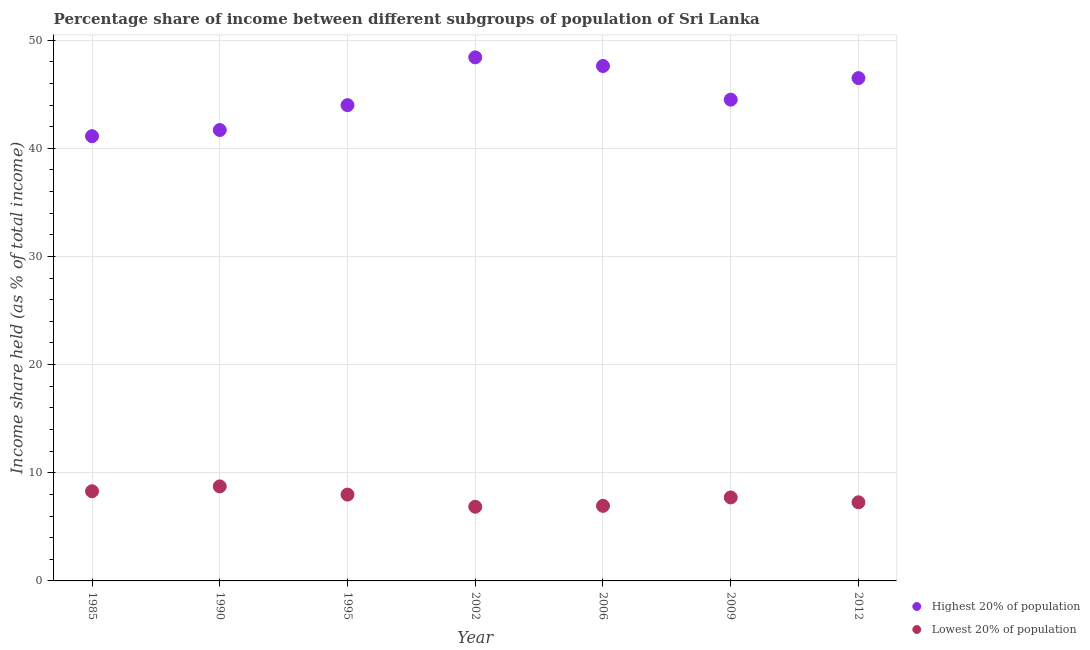What is the income share held by highest 20% of the population in 1985?
Provide a short and direct response. 41.12. Across all years, what is the maximum income share held by lowest 20% of the population?
Offer a terse response. 8.74. Across all years, what is the minimum income share held by highest 20% of the population?
Give a very brief answer. 41.12. In which year was the income share held by highest 20% of the population minimum?
Offer a very short reply. 1985. What is the total income share held by lowest 20% of the population in the graph?
Provide a short and direct response. 53.8. What is the difference between the income share held by lowest 20% of the population in 2002 and that in 2009?
Give a very brief answer. -0.86. What is the difference between the income share held by lowest 20% of the population in 2002 and the income share held by highest 20% of the population in 1995?
Your response must be concise. -37.13. What is the average income share held by highest 20% of the population per year?
Offer a terse response. 44.83. In the year 1990, what is the difference between the income share held by lowest 20% of the population and income share held by highest 20% of the population?
Your answer should be very brief. -32.95. What is the ratio of the income share held by lowest 20% of the population in 2002 to that in 2012?
Ensure brevity in your answer.  0.94. Is the income share held by highest 20% of the population in 1985 less than that in 1990?
Offer a very short reply. Yes. Is the difference between the income share held by lowest 20% of the population in 2002 and 2012 greater than the difference between the income share held by highest 20% of the population in 2002 and 2012?
Keep it short and to the point. No. What is the difference between the highest and the second highest income share held by highest 20% of the population?
Keep it short and to the point. 0.8. What is the difference between the highest and the lowest income share held by highest 20% of the population?
Provide a succinct answer. 7.29. Is the sum of the income share held by lowest 20% of the population in 2006 and 2009 greater than the maximum income share held by highest 20% of the population across all years?
Keep it short and to the point. No. Does the income share held by highest 20% of the population monotonically increase over the years?
Your answer should be very brief. No. Is the income share held by highest 20% of the population strictly greater than the income share held by lowest 20% of the population over the years?
Your response must be concise. Yes. Is the income share held by highest 20% of the population strictly less than the income share held by lowest 20% of the population over the years?
Offer a very short reply. No. How many years are there in the graph?
Ensure brevity in your answer.  7. Are the values on the major ticks of Y-axis written in scientific E-notation?
Offer a very short reply. No. Does the graph contain any zero values?
Your answer should be very brief. No. How are the legend labels stacked?
Offer a very short reply. Vertical. What is the title of the graph?
Your answer should be compact. Percentage share of income between different subgroups of population of Sri Lanka. Does "Private creditors" appear as one of the legend labels in the graph?
Your response must be concise. No. What is the label or title of the X-axis?
Provide a short and direct response. Year. What is the label or title of the Y-axis?
Provide a succinct answer. Income share held (as % of total income). What is the Income share held (as % of total income) of Highest 20% of population in 1985?
Offer a very short reply. 41.12. What is the Income share held (as % of total income) in Lowest 20% of population in 1985?
Provide a short and direct response. 8.29. What is the Income share held (as % of total income) in Highest 20% of population in 1990?
Your response must be concise. 41.69. What is the Income share held (as % of total income) of Lowest 20% of population in 1990?
Offer a very short reply. 8.74. What is the Income share held (as % of total income) in Highest 20% of population in 1995?
Keep it short and to the point. 43.99. What is the Income share held (as % of total income) in Lowest 20% of population in 1995?
Give a very brief answer. 7.98. What is the Income share held (as % of total income) in Highest 20% of population in 2002?
Provide a short and direct response. 48.41. What is the Income share held (as % of total income) of Lowest 20% of population in 2002?
Offer a terse response. 6.86. What is the Income share held (as % of total income) in Highest 20% of population in 2006?
Your answer should be very brief. 47.61. What is the Income share held (as % of total income) in Lowest 20% of population in 2006?
Offer a very short reply. 6.94. What is the Income share held (as % of total income) of Highest 20% of population in 2009?
Offer a terse response. 44.5. What is the Income share held (as % of total income) in Lowest 20% of population in 2009?
Ensure brevity in your answer.  7.72. What is the Income share held (as % of total income) of Highest 20% of population in 2012?
Ensure brevity in your answer.  46.49. What is the Income share held (as % of total income) in Lowest 20% of population in 2012?
Provide a short and direct response. 7.27. Across all years, what is the maximum Income share held (as % of total income) in Highest 20% of population?
Make the answer very short. 48.41. Across all years, what is the maximum Income share held (as % of total income) of Lowest 20% of population?
Your response must be concise. 8.74. Across all years, what is the minimum Income share held (as % of total income) in Highest 20% of population?
Keep it short and to the point. 41.12. Across all years, what is the minimum Income share held (as % of total income) of Lowest 20% of population?
Keep it short and to the point. 6.86. What is the total Income share held (as % of total income) of Highest 20% of population in the graph?
Your answer should be compact. 313.81. What is the total Income share held (as % of total income) of Lowest 20% of population in the graph?
Offer a very short reply. 53.8. What is the difference between the Income share held (as % of total income) of Highest 20% of population in 1985 and that in 1990?
Offer a very short reply. -0.57. What is the difference between the Income share held (as % of total income) in Lowest 20% of population in 1985 and that in 1990?
Offer a very short reply. -0.45. What is the difference between the Income share held (as % of total income) in Highest 20% of population in 1985 and that in 1995?
Offer a terse response. -2.87. What is the difference between the Income share held (as % of total income) of Lowest 20% of population in 1985 and that in 1995?
Make the answer very short. 0.31. What is the difference between the Income share held (as % of total income) in Highest 20% of population in 1985 and that in 2002?
Make the answer very short. -7.29. What is the difference between the Income share held (as % of total income) in Lowest 20% of population in 1985 and that in 2002?
Your answer should be compact. 1.43. What is the difference between the Income share held (as % of total income) in Highest 20% of population in 1985 and that in 2006?
Your answer should be compact. -6.49. What is the difference between the Income share held (as % of total income) of Lowest 20% of population in 1985 and that in 2006?
Provide a succinct answer. 1.35. What is the difference between the Income share held (as % of total income) of Highest 20% of population in 1985 and that in 2009?
Provide a short and direct response. -3.38. What is the difference between the Income share held (as % of total income) in Lowest 20% of population in 1985 and that in 2009?
Your answer should be compact. 0.57. What is the difference between the Income share held (as % of total income) of Highest 20% of population in 1985 and that in 2012?
Make the answer very short. -5.37. What is the difference between the Income share held (as % of total income) in Lowest 20% of population in 1985 and that in 2012?
Provide a short and direct response. 1.02. What is the difference between the Income share held (as % of total income) in Highest 20% of population in 1990 and that in 1995?
Provide a short and direct response. -2.3. What is the difference between the Income share held (as % of total income) of Lowest 20% of population in 1990 and that in 1995?
Provide a succinct answer. 0.76. What is the difference between the Income share held (as % of total income) in Highest 20% of population in 1990 and that in 2002?
Offer a terse response. -6.72. What is the difference between the Income share held (as % of total income) in Lowest 20% of population in 1990 and that in 2002?
Your answer should be compact. 1.88. What is the difference between the Income share held (as % of total income) in Highest 20% of population in 1990 and that in 2006?
Offer a very short reply. -5.92. What is the difference between the Income share held (as % of total income) in Highest 20% of population in 1990 and that in 2009?
Give a very brief answer. -2.81. What is the difference between the Income share held (as % of total income) in Highest 20% of population in 1990 and that in 2012?
Provide a succinct answer. -4.8. What is the difference between the Income share held (as % of total income) of Lowest 20% of population in 1990 and that in 2012?
Make the answer very short. 1.47. What is the difference between the Income share held (as % of total income) of Highest 20% of population in 1995 and that in 2002?
Provide a short and direct response. -4.42. What is the difference between the Income share held (as % of total income) of Lowest 20% of population in 1995 and that in 2002?
Your response must be concise. 1.12. What is the difference between the Income share held (as % of total income) in Highest 20% of population in 1995 and that in 2006?
Keep it short and to the point. -3.62. What is the difference between the Income share held (as % of total income) of Highest 20% of population in 1995 and that in 2009?
Your answer should be compact. -0.51. What is the difference between the Income share held (as % of total income) of Lowest 20% of population in 1995 and that in 2009?
Ensure brevity in your answer.  0.26. What is the difference between the Income share held (as % of total income) of Highest 20% of population in 1995 and that in 2012?
Offer a terse response. -2.5. What is the difference between the Income share held (as % of total income) in Lowest 20% of population in 1995 and that in 2012?
Provide a short and direct response. 0.71. What is the difference between the Income share held (as % of total income) in Lowest 20% of population in 2002 and that in 2006?
Keep it short and to the point. -0.08. What is the difference between the Income share held (as % of total income) in Highest 20% of population in 2002 and that in 2009?
Your answer should be very brief. 3.91. What is the difference between the Income share held (as % of total income) of Lowest 20% of population in 2002 and that in 2009?
Offer a very short reply. -0.86. What is the difference between the Income share held (as % of total income) in Highest 20% of population in 2002 and that in 2012?
Your answer should be very brief. 1.92. What is the difference between the Income share held (as % of total income) in Lowest 20% of population in 2002 and that in 2012?
Give a very brief answer. -0.41. What is the difference between the Income share held (as % of total income) of Highest 20% of population in 2006 and that in 2009?
Provide a short and direct response. 3.11. What is the difference between the Income share held (as % of total income) in Lowest 20% of population in 2006 and that in 2009?
Give a very brief answer. -0.78. What is the difference between the Income share held (as % of total income) of Highest 20% of population in 2006 and that in 2012?
Provide a succinct answer. 1.12. What is the difference between the Income share held (as % of total income) in Lowest 20% of population in 2006 and that in 2012?
Make the answer very short. -0.33. What is the difference between the Income share held (as % of total income) of Highest 20% of population in 2009 and that in 2012?
Your answer should be compact. -1.99. What is the difference between the Income share held (as % of total income) of Lowest 20% of population in 2009 and that in 2012?
Offer a terse response. 0.45. What is the difference between the Income share held (as % of total income) of Highest 20% of population in 1985 and the Income share held (as % of total income) of Lowest 20% of population in 1990?
Your answer should be very brief. 32.38. What is the difference between the Income share held (as % of total income) of Highest 20% of population in 1985 and the Income share held (as % of total income) of Lowest 20% of population in 1995?
Keep it short and to the point. 33.14. What is the difference between the Income share held (as % of total income) of Highest 20% of population in 1985 and the Income share held (as % of total income) of Lowest 20% of population in 2002?
Ensure brevity in your answer.  34.26. What is the difference between the Income share held (as % of total income) of Highest 20% of population in 1985 and the Income share held (as % of total income) of Lowest 20% of population in 2006?
Offer a very short reply. 34.18. What is the difference between the Income share held (as % of total income) of Highest 20% of population in 1985 and the Income share held (as % of total income) of Lowest 20% of population in 2009?
Your response must be concise. 33.4. What is the difference between the Income share held (as % of total income) of Highest 20% of population in 1985 and the Income share held (as % of total income) of Lowest 20% of population in 2012?
Your response must be concise. 33.85. What is the difference between the Income share held (as % of total income) in Highest 20% of population in 1990 and the Income share held (as % of total income) in Lowest 20% of population in 1995?
Ensure brevity in your answer.  33.71. What is the difference between the Income share held (as % of total income) of Highest 20% of population in 1990 and the Income share held (as % of total income) of Lowest 20% of population in 2002?
Make the answer very short. 34.83. What is the difference between the Income share held (as % of total income) in Highest 20% of population in 1990 and the Income share held (as % of total income) in Lowest 20% of population in 2006?
Your answer should be very brief. 34.75. What is the difference between the Income share held (as % of total income) in Highest 20% of population in 1990 and the Income share held (as % of total income) in Lowest 20% of population in 2009?
Offer a very short reply. 33.97. What is the difference between the Income share held (as % of total income) of Highest 20% of population in 1990 and the Income share held (as % of total income) of Lowest 20% of population in 2012?
Offer a terse response. 34.42. What is the difference between the Income share held (as % of total income) in Highest 20% of population in 1995 and the Income share held (as % of total income) in Lowest 20% of population in 2002?
Your answer should be compact. 37.13. What is the difference between the Income share held (as % of total income) of Highest 20% of population in 1995 and the Income share held (as % of total income) of Lowest 20% of population in 2006?
Provide a succinct answer. 37.05. What is the difference between the Income share held (as % of total income) in Highest 20% of population in 1995 and the Income share held (as % of total income) in Lowest 20% of population in 2009?
Offer a very short reply. 36.27. What is the difference between the Income share held (as % of total income) of Highest 20% of population in 1995 and the Income share held (as % of total income) of Lowest 20% of population in 2012?
Provide a succinct answer. 36.72. What is the difference between the Income share held (as % of total income) in Highest 20% of population in 2002 and the Income share held (as % of total income) in Lowest 20% of population in 2006?
Give a very brief answer. 41.47. What is the difference between the Income share held (as % of total income) in Highest 20% of population in 2002 and the Income share held (as % of total income) in Lowest 20% of population in 2009?
Your response must be concise. 40.69. What is the difference between the Income share held (as % of total income) of Highest 20% of population in 2002 and the Income share held (as % of total income) of Lowest 20% of population in 2012?
Provide a succinct answer. 41.14. What is the difference between the Income share held (as % of total income) in Highest 20% of population in 2006 and the Income share held (as % of total income) in Lowest 20% of population in 2009?
Offer a terse response. 39.89. What is the difference between the Income share held (as % of total income) in Highest 20% of population in 2006 and the Income share held (as % of total income) in Lowest 20% of population in 2012?
Provide a short and direct response. 40.34. What is the difference between the Income share held (as % of total income) of Highest 20% of population in 2009 and the Income share held (as % of total income) of Lowest 20% of population in 2012?
Ensure brevity in your answer.  37.23. What is the average Income share held (as % of total income) in Highest 20% of population per year?
Keep it short and to the point. 44.83. What is the average Income share held (as % of total income) in Lowest 20% of population per year?
Make the answer very short. 7.69. In the year 1985, what is the difference between the Income share held (as % of total income) of Highest 20% of population and Income share held (as % of total income) of Lowest 20% of population?
Offer a very short reply. 32.83. In the year 1990, what is the difference between the Income share held (as % of total income) in Highest 20% of population and Income share held (as % of total income) in Lowest 20% of population?
Your answer should be very brief. 32.95. In the year 1995, what is the difference between the Income share held (as % of total income) in Highest 20% of population and Income share held (as % of total income) in Lowest 20% of population?
Your response must be concise. 36.01. In the year 2002, what is the difference between the Income share held (as % of total income) in Highest 20% of population and Income share held (as % of total income) in Lowest 20% of population?
Offer a very short reply. 41.55. In the year 2006, what is the difference between the Income share held (as % of total income) of Highest 20% of population and Income share held (as % of total income) of Lowest 20% of population?
Your answer should be very brief. 40.67. In the year 2009, what is the difference between the Income share held (as % of total income) in Highest 20% of population and Income share held (as % of total income) in Lowest 20% of population?
Your answer should be compact. 36.78. In the year 2012, what is the difference between the Income share held (as % of total income) in Highest 20% of population and Income share held (as % of total income) in Lowest 20% of population?
Give a very brief answer. 39.22. What is the ratio of the Income share held (as % of total income) of Highest 20% of population in 1985 to that in 1990?
Provide a succinct answer. 0.99. What is the ratio of the Income share held (as % of total income) in Lowest 20% of population in 1985 to that in 1990?
Make the answer very short. 0.95. What is the ratio of the Income share held (as % of total income) of Highest 20% of population in 1985 to that in 1995?
Your response must be concise. 0.93. What is the ratio of the Income share held (as % of total income) of Lowest 20% of population in 1985 to that in 1995?
Provide a short and direct response. 1.04. What is the ratio of the Income share held (as % of total income) of Highest 20% of population in 1985 to that in 2002?
Offer a terse response. 0.85. What is the ratio of the Income share held (as % of total income) of Lowest 20% of population in 1985 to that in 2002?
Keep it short and to the point. 1.21. What is the ratio of the Income share held (as % of total income) in Highest 20% of population in 1985 to that in 2006?
Your response must be concise. 0.86. What is the ratio of the Income share held (as % of total income) in Lowest 20% of population in 1985 to that in 2006?
Give a very brief answer. 1.19. What is the ratio of the Income share held (as % of total income) in Highest 20% of population in 1985 to that in 2009?
Offer a terse response. 0.92. What is the ratio of the Income share held (as % of total income) of Lowest 20% of population in 1985 to that in 2009?
Ensure brevity in your answer.  1.07. What is the ratio of the Income share held (as % of total income) of Highest 20% of population in 1985 to that in 2012?
Provide a short and direct response. 0.88. What is the ratio of the Income share held (as % of total income) of Lowest 20% of population in 1985 to that in 2012?
Provide a short and direct response. 1.14. What is the ratio of the Income share held (as % of total income) in Highest 20% of population in 1990 to that in 1995?
Make the answer very short. 0.95. What is the ratio of the Income share held (as % of total income) of Lowest 20% of population in 1990 to that in 1995?
Your answer should be very brief. 1.1. What is the ratio of the Income share held (as % of total income) of Highest 20% of population in 1990 to that in 2002?
Provide a succinct answer. 0.86. What is the ratio of the Income share held (as % of total income) of Lowest 20% of population in 1990 to that in 2002?
Provide a succinct answer. 1.27. What is the ratio of the Income share held (as % of total income) in Highest 20% of population in 1990 to that in 2006?
Your response must be concise. 0.88. What is the ratio of the Income share held (as % of total income) in Lowest 20% of population in 1990 to that in 2006?
Your answer should be very brief. 1.26. What is the ratio of the Income share held (as % of total income) in Highest 20% of population in 1990 to that in 2009?
Make the answer very short. 0.94. What is the ratio of the Income share held (as % of total income) in Lowest 20% of population in 1990 to that in 2009?
Offer a terse response. 1.13. What is the ratio of the Income share held (as % of total income) in Highest 20% of population in 1990 to that in 2012?
Your answer should be very brief. 0.9. What is the ratio of the Income share held (as % of total income) of Lowest 20% of population in 1990 to that in 2012?
Ensure brevity in your answer.  1.2. What is the ratio of the Income share held (as % of total income) of Highest 20% of population in 1995 to that in 2002?
Provide a succinct answer. 0.91. What is the ratio of the Income share held (as % of total income) in Lowest 20% of population in 1995 to that in 2002?
Your response must be concise. 1.16. What is the ratio of the Income share held (as % of total income) of Highest 20% of population in 1995 to that in 2006?
Ensure brevity in your answer.  0.92. What is the ratio of the Income share held (as % of total income) of Lowest 20% of population in 1995 to that in 2006?
Offer a terse response. 1.15. What is the ratio of the Income share held (as % of total income) in Highest 20% of population in 1995 to that in 2009?
Make the answer very short. 0.99. What is the ratio of the Income share held (as % of total income) of Lowest 20% of population in 1995 to that in 2009?
Your answer should be compact. 1.03. What is the ratio of the Income share held (as % of total income) in Highest 20% of population in 1995 to that in 2012?
Keep it short and to the point. 0.95. What is the ratio of the Income share held (as % of total income) in Lowest 20% of population in 1995 to that in 2012?
Offer a very short reply. 1.1. What is the ratio of the Income share held (as % of total income) in Highest 20% of population in 2002 to that in 2006?
Offer a very short reply. 1.02. What is the ratio of the Income share held (as % of total income) in Lowest 20% of population in 2002 to that in 2006?
Make the answer very short. 0.99. What is the ratio of the Income share held (as % of total income) of Highest 20% of population in 2002 to that in 2009?
Keep it short and to the point. 1.09. What is the ratio of the Income share held (as % of total income) of Lowest 20% of population in 2002 to that in 2009?
Keep it short and to the point. 0.89. What is the ratio of the Income share held (as % of total income) of Highest 20% of population in 2002 to that in 2012?
Keep it short and to the point. 1.04. What is the ratio of the Income share held (as % of total income) of Lowest 20% of population in 2002 to that in 2012?
Provide a succinct answer. 0.94. What is the ratio of the Income share held (as % of total income) in Highest 20% of population in 2006 to that in 2009?
Keep it short and to the point. 1.07. What is the ratio of the Income share held (as % of total income) of Lowest 20% of population in 2006 to that in 2009?
Offer a very short reply. 0.9. What is the ratio of the Income share held (as % of total income) in Highest 20% of population in 2006 to that in 2012?
Make the answer very short. 1.02. What is the ratio of the Income share held (as % of total income) in Lowest 20% of population in 2006 to that in 2012?
Ensure brevity in your answer.  0.95. What is the ratio of the Income share held (as % of total income) in Highest 20% of population in 2009 to that in 2012?
Provide a short and direct response. 0.96. What is the ratio of the Income share held (as % of total income) of Lowest 20% of population in 2009 to that in 2012?
Your answer should be very brief. 1.06. What is the difference between the highest and the second highest Income share held (as % of total income) in Highest 20% of population?
Make the answer very short. 0.8. What is the difference between the highest and the second highest Income share held (as % of total income) in Lowest 20% of population?
Your answer should be very brief. 0.45. What is the difference between the highest and the lowest Income share held (as % of total income) of Highest 20% of population?
Provide a short and direct response. 7.29. What is the difference between the highest and the lowest Income share held (as % of total income) of Lowest 20% of population?
Offer a terse response. 1.88. 